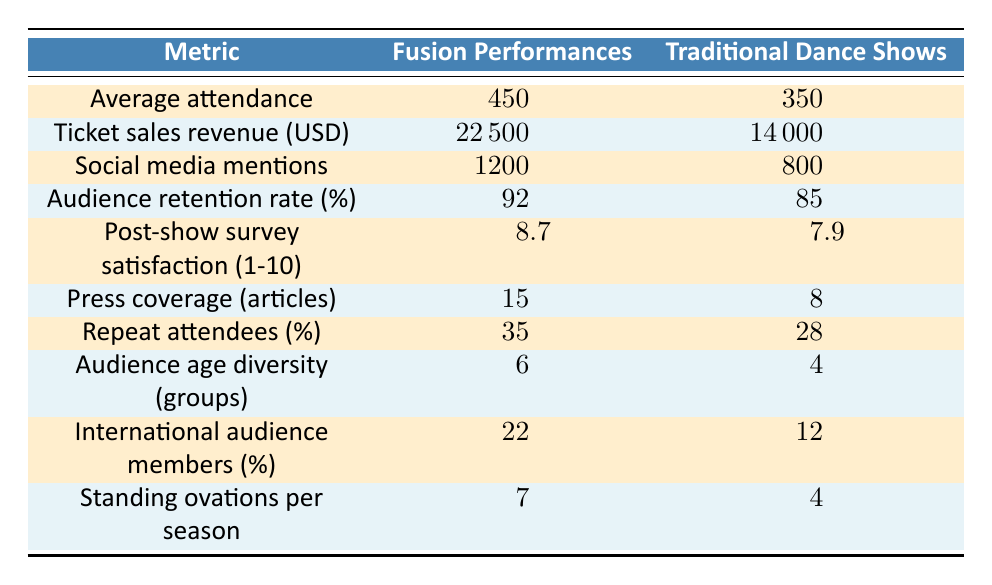What is the average attendance for fusion performances? The table clearly states that the average attendance for fusion performances is 450.
Answer: 450 How much ticket sales revenue did traditional dance shows generate? According to the table, traditional dance shows generated a ticket sales revenue of 14000 USD.
Answer: 14000 Which performance type had a higher audience retention rate? The table shows that fusion performances had a retention rate of 92%, while traditional dance shows had 85%. Thus, fusion performances had a higher rate.
Answer: Fusion performances What is the difference in social media mentions between fusion performances and traditional dance shows? The social media mentions for fusion performances are 1200, while for traditional dance shows it is 800. The difference is calculated as 1200 - 800 = 400.
Answer: 400 Do fusion performances have more international audience members as a percentage compared to traditional dance shows? The table indicates that 22% of the audience for fusion performances was international, compared to 12% for traditional dance shows. Thus, the statement is true.
Answer: Yes What is the combined average rating for emotional impact from both types of performances? The average rating for emotional impact for fusion performances is 8.9, and for traditional dance shows, it is 8.7. Adding these values gives 8.9 + 8.7 = 17.6, and dividing by 2 gives an average of 8.8.
Answer: 8.8 Which performance type had more standing ovations per season? Fusion performances had 7 standing ovations per season, while traditional dance shows had 4. Thus, fusion performances had more.
Answer: Fusion performances Is the post-show survey satisfaction rating for fusion performances higher than for traditional dance shows? The table lists a satisfaction rating of 8.7 for fusion performances and 7.9 for traditional dance shows. Since 8.7 is greater than 7.9, the statement is true.
Answer: Yes How many more press coverage articles were written about fusion performances compared to traditional dance shows? The number of press coverage articles is 15 for fusion performances and 8 for traditional dance shows. The difference is 15 - 8 = 7 articles.
Answer: 7 